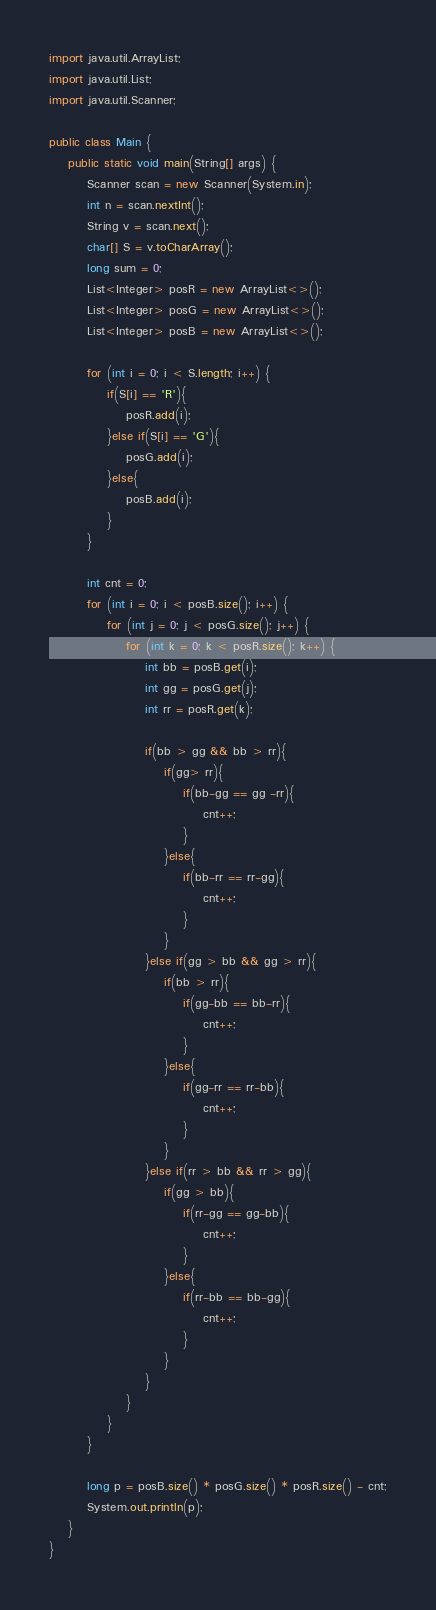<code> <loc_0><loc_0><loc_500><loc_500><_Java_>import java.util.ArrayList;
import java.util.List;
import java.util.Scanner;

public class Main {
    public static void main(String[] args) {
        Scanner scan = new Scanner(System.in);
        int n = scan.nextInt();
        String v = scan.next();
        char[] S = v.toCharArray();
        long sum = 0;
        List<Integer> posR = new ArrayList<>();
        List<Integer> posG = new ArrayList<>();
        List<Integer> posB = new ArrayList<>();

        for (int i = 0; i < S.length; i++) {
            if(S[i] == 'R'){
                posR.add(i);
            }else if(S[i] == 'G'){
                posG.add(i);
            }else{
                posB.add(i);
            }
        }

        int cnt = 0;
        for (int i = 0; i < posB.size(); i++) {
            for (int j = 0; j < posG.size(); j++) {
                for (int k = 0; k < posR.size(); k++) {
                    int bb = posB.get(i);
                    int gg = posG.get(j);
                    int rr = posR.get(k);

                    if(bb > gg && bb > rr){
                        if(gg> rr){
                            if(bb-gg == gg -rr){
                                cnt++;
                            }
                        }else{
                            if(bb-rr == rr-gg){
                                cnt++;
                            }
                        }
                    }else if(gg > bb && gg > rr){
                        if(bb > rr){
                            if(gg-bb == bb-rr){
                                cnt++;
                            }
                        }else{
                            if(gg-rr == rr-bb){
                                cnt++;
                            }
                        }
                    }else if(rr > bb && rr > gg){
                        if(gg > bb){
                            if(rr-gg == gg-bb){
                                cnt++;
                            }
                        }else{
                            if(rr-bb == bb-gg){
                                cnt++;
                            }
                        }
                    }
                }
            }
        }

        long p = posB.size() * posG.size() * posR.size() - cnt;
        System.out.println(p);
    }
}
</code> 